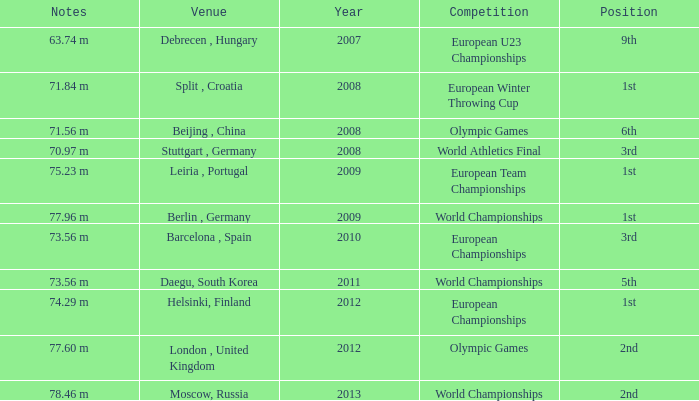What was the venue after 2012? Moscow, Russia. Can you parse all the data within this table? {'header': ['Notes', 'Venue', 'Year', 'Competition', 'Position'], 'rows': [['63.74 m', 'Debrecen , Hungary', '2007', 'European U23 Championships', '9th'], ['71.84 m', 'Split , Croatia', '2008', 'European Winter Throwing Cup', '1st'], ['71.56 m', 'Beijing , China', '2008', 'Olympic Games', '6th'], ['70.97 m', 'Stuttgart , Germany', '2008', 'World Athletics Final', '3rd'], ['75.23 m', 'Leiria , Portugal', '2009', 'European Team Championships', '1st'], ['77.96 m', 'Berlin , Germany', '2009', 'World Championships', '1st'], ['73.56 m', 'Barcelona , Spain', '2010', 'European Championships', '3rd'], ['73.56 m', 'Daegu, South Korea', '2011', 'World Championships', '5th'], ['74.29 m', 'Helsinki, Finland', '2012', 'European Championships', '1st'], ['77.60 m', 'London , United Kingdom', '2012', 'Olympic Games', '2nd'], ['78.46 m', 'Moscow, Russia', '2013', 'World Championships', '2nd']]} 